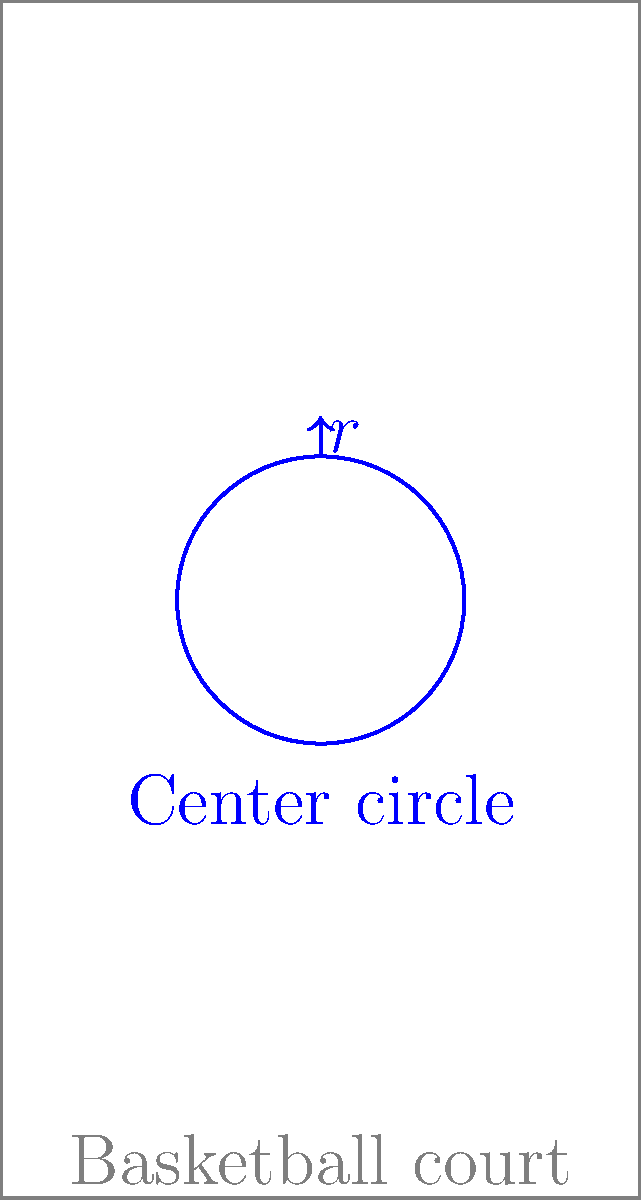While scouting in New Zealand, you notice that the center circle of a basketball court has a circumference of $11.31$ meters. What is the radius of this center circle to the nearest centimeter? To find the radius of the center circle, we'll use the formula for the circumference of a circle and solve for the radius. Here's the step-by-step process:

1) The formula for the circumference of a circle is:
   $$C = 2\pi r$$
   where $C$ is the circumference and $r$ is the radius.

2) We're given that the circumference is 11.31 meters. Let's substitute this into our equation:
   $$11.31 = 2\pi r$$

3) To solve for $r$, we need to divide both sides by $2\pi$:
   $$\frac{11.31}{2\pi} = r$$

4) Let's calculate this:
   $$r = \frac{11.31}{2\pi} \approx 1.8$$

5) Converting to centimeters:
   $$1.8 \text{ meters} = 180 \text{ centimeters}$$

Therefore, the radius of the center circle is 180 cm.
Answer: 180 cm 